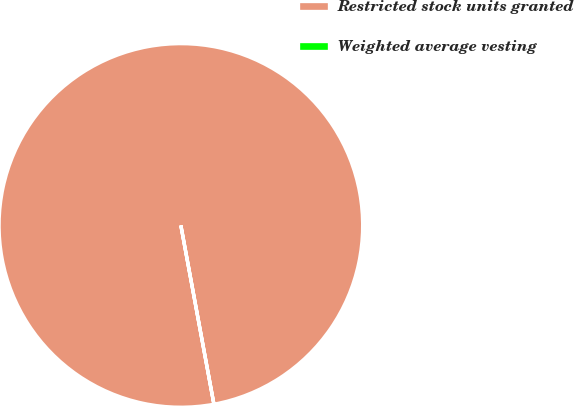Convert chart to OTSL. <chart><loc_0><loc_0><loc_500><loc_500><pie_chart><fcel>Restricted stock units granted<fcel>Weighted average vesting<nl><fcel>100.0%<fcel>0.0%<nl></chart> 